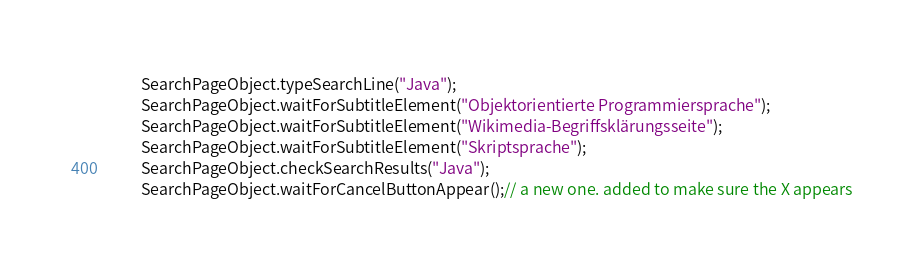Convert code to text. <code><loc_0><loc_0><loc_500><loc_500><_Java_>        SearchPageObject.typeSearchLine("Java");
        SearchPageObject.waitForSubtitleElement("Objektorientierte Programmiersprache");
        SearchPageObject.waitForSubtitleElement("Wikimedia-Begriffsklärungsseite");
        SearchPageObject.waitForSubtitleElement("Skriptsprache");
        SearchPageObject.checkSearchResults("Java");
        SearchPageObject.waitForCancelButtonAppear();// a new one. added to make sure the X appears</code> 